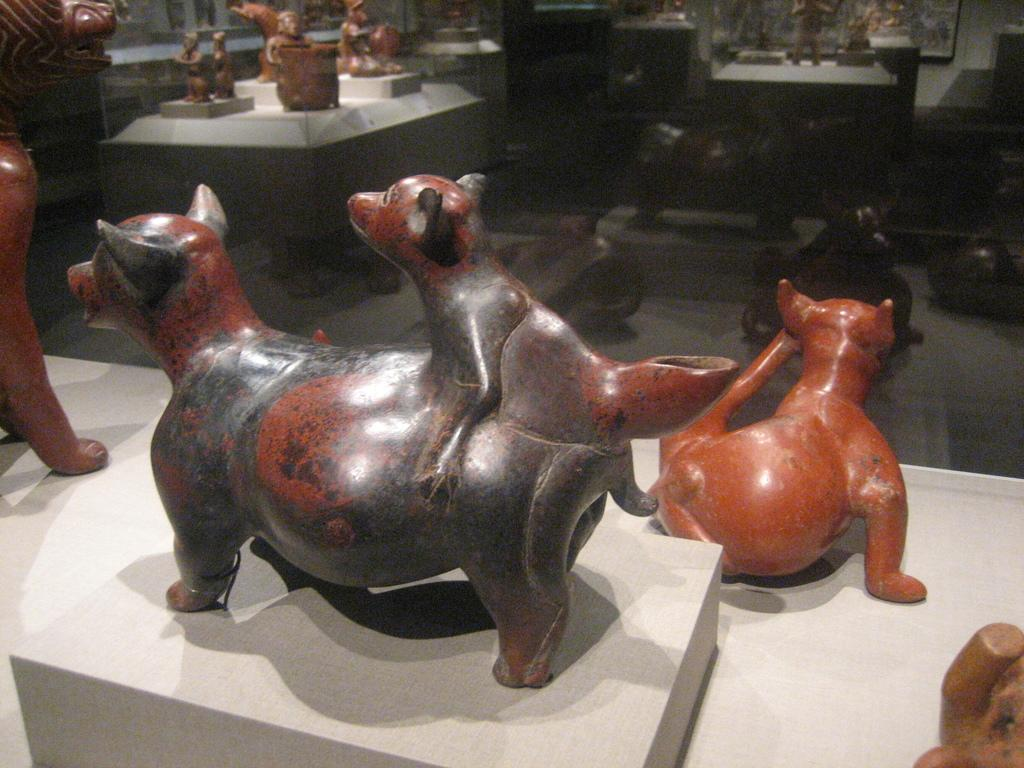What can be seen in the foreground of the image? There are sculptures placed on a surface in the foreground of the image. What is present in the background of the image? There are different types of sculptures placed on a surface in the background of the image. How many bananas are being kissed by the horses in the image? There are no bananas or horses present in the image; it features sculptures on a surface. 